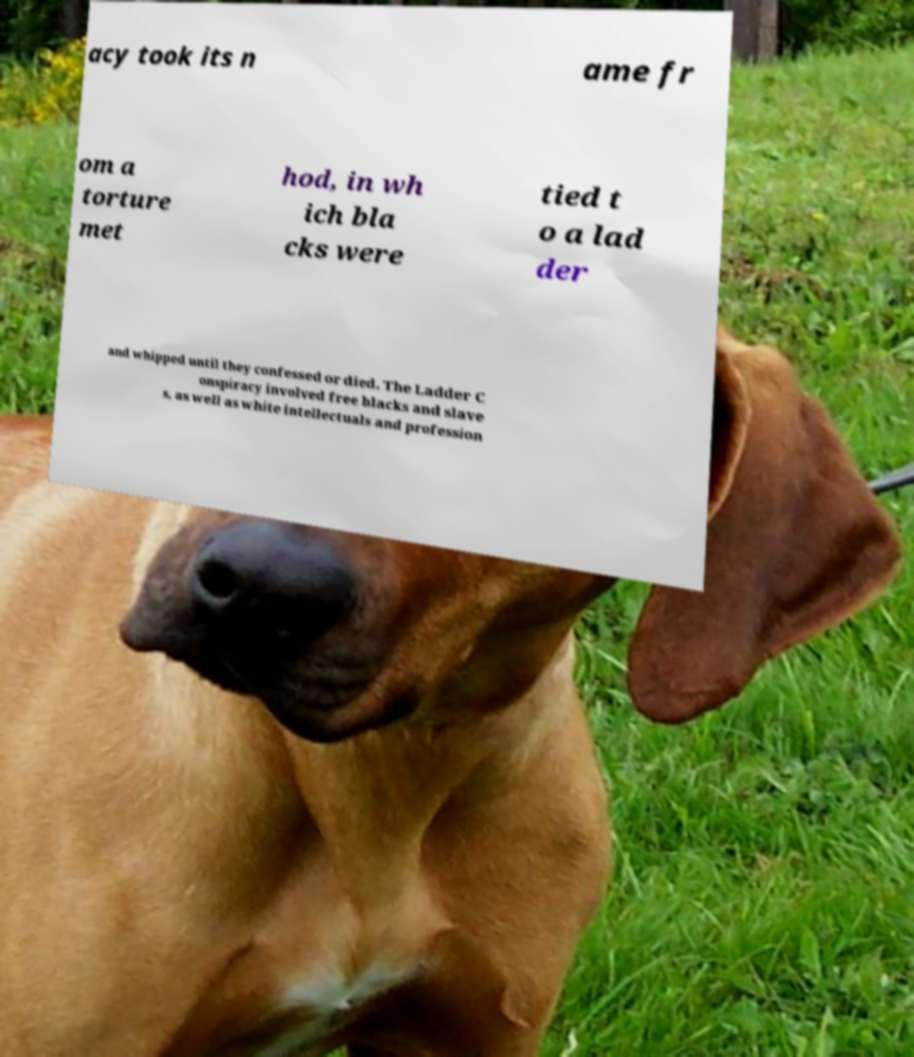Please identify and transcribe the text found in this image. acy took its n ame fr om a torture met hod, in wh ich bla cks were tied t o a lad der and whipped until they confessed or died. The Ladder C onspiracy involved free blacks and slave s, as well as white intellectuals and profession 